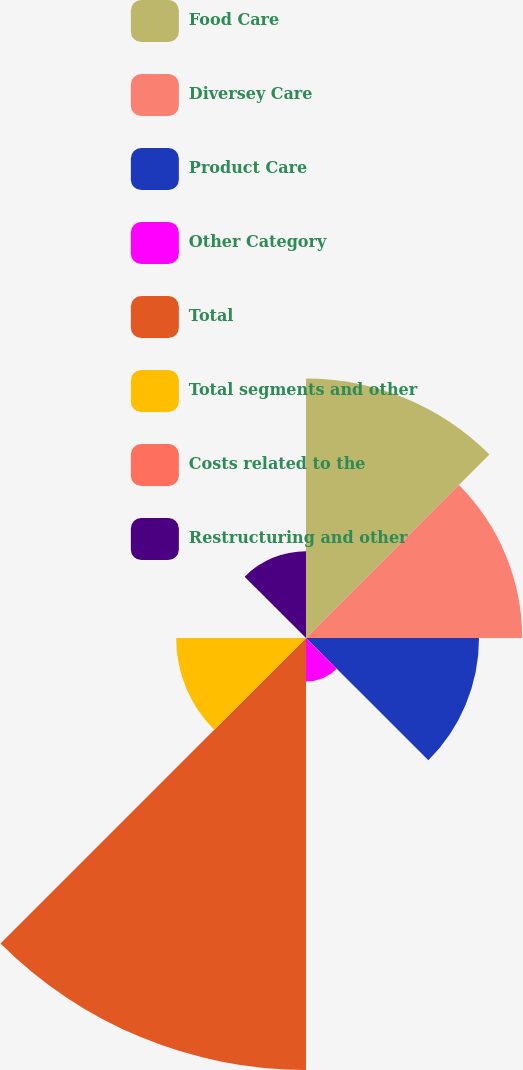Convert chart. <chart><loc_0><loc_0><loc_500><loc_500><pie_chart><fcel>Food Care<fcel>Diversey Care<fcel>Product Care<fcel>Other Category<fcel>Total<fcel>Total segments and other<fcel>Costs related to the<fcel>Restructuring and other<nl><fcel>19.34%<fcel>16.12%<fcel>12.9%<fcel>3.25%<fcel>32.21%<fcel>9.68%<fcel>0.03%<fcel>6.47%<nl></chart> 